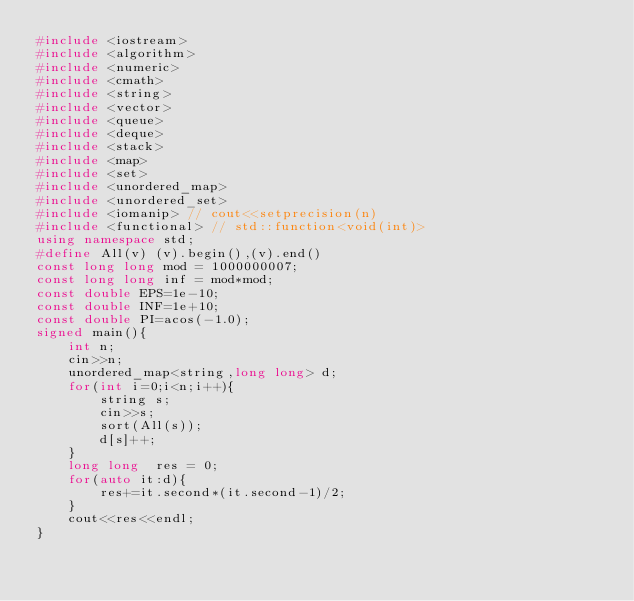Convert code to text. <code><loc_0><loc_0><loc_500><loc_500><_C++_>#include <iostream>
#include <algorithm>
#include <numeric>
#include <cmath>
#include <string>
#include <vector>
#include <queue>
#include <deque>
#include <stack>
#include <map>
#include <set>
#include <unordered_map>
#include <unordered_set>
#include <iomanip> // cout<<setprecision(n)
#include <functional> // std::function<void(int)>
using namespace std;
#define All(v) (v).begin(),(v).end()
const long long mod = 1000000007;
const long long inf = mod*mod;
const double EPS=1e-10;
const double INF=1e+10;
const double PI=acos(-1.0);
signed main(){
    int n;
    cin>>n;
    unordered_map<string,long long> d;
    for(int i=0;i<n;i++){
        string s;
        cin>>s;
        sort(All(s));
        d[s]++;
    }
    long long  res = 0;
    for(auto it:d){
        res+=it.second*(it.second-1)/2;
    }
    cout<<res<<endl;
}</code> 